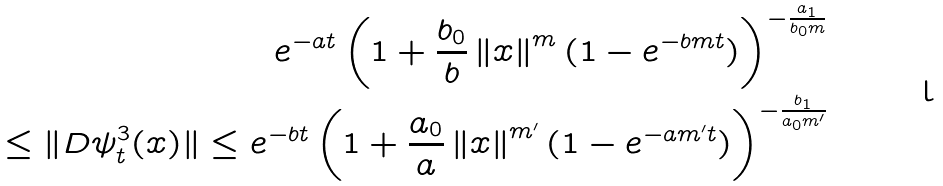<formula> <loc_0><loc_0><loc_500><loc_500>e ^ { - a t } \left ( 1 + \frac { b _ { 0 } } { b } \left \| x \right \| ^ { m } ( 1 - e ^ { - b m t } ) \right ) ^ { - \frac { a _ { 1 } } { b _ { 0 } m } } \\ \leq \| D \psi _ { t } ^ { 3 } ( x ) \| \leq e ^ { - b t } \left ( 1 + \frac { a _ { 0 } } { a } \left \| x \right \| ^ { m ^ { \prime } } ( 1 - e ^ { - a m ^ { \prime } t } ) \right ) ^ { - \frac { b _ { 1 } } { a _ { 0 } m ^ { \prime } } }</formula> 